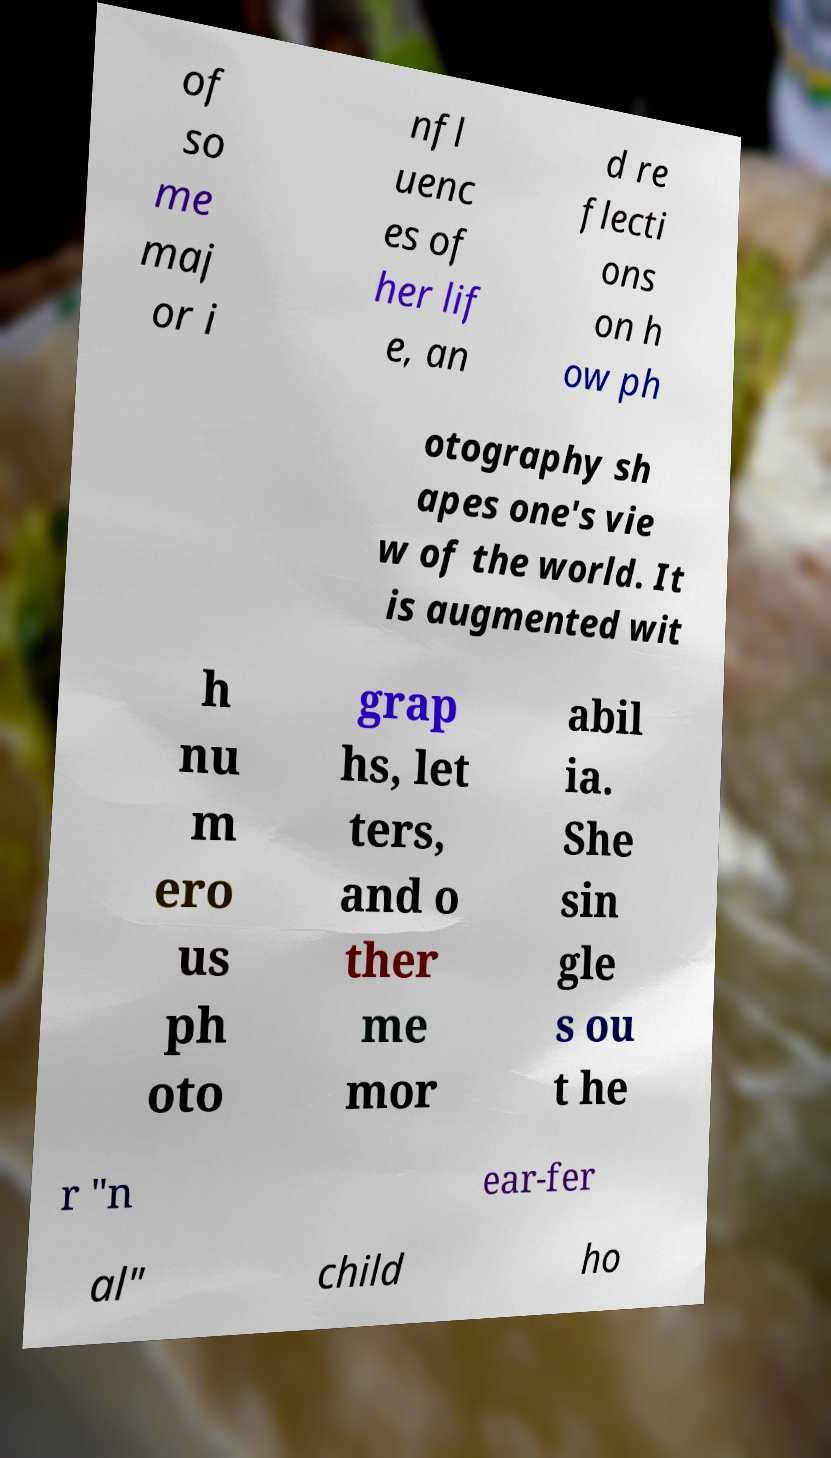For documentation purposes, I need the text within this image transcribed. Could you provide that? of so me maj or i nfl uenc es of her lif e, an d re flecti ons on h ow ph otography sh apes one's vie w of the world. It is augmented wit h nu m ero us ph oto grap hs, let ters, and o ther me mor abil ia. She sin gle s ou t he r "n ear-fer al" child ho 